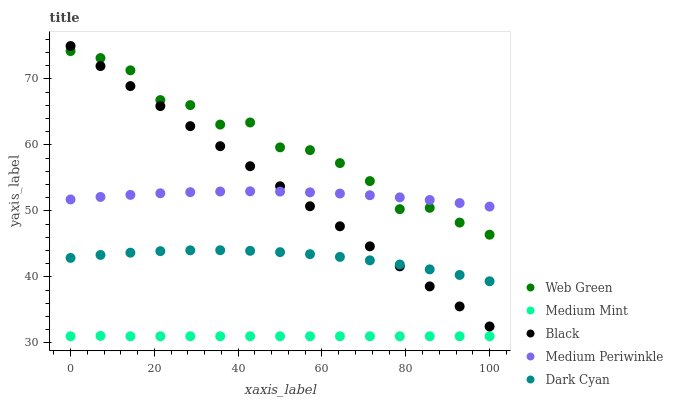Does Medium Mint have the minimum area under the curve?
Answer yes or no. Yes. Does Web Green have the maximum area under the curve?
Answer yes or no. Yes. Does Medium Periwinkle have the minimum area under the curve?
Answer yes or no. No. Does Medium Periwinkle have the maximum area under the curve?
Answer yes or no. No. Is Black the smoothest?
Answer yes or no. Yes. Is Web Green the roughest?
Answer yes or no. Yes. Is Medium Periwinkle the smoothest?
Answer yes or no. No. Is Medium Periwinkle the roughest?
Answer yes or no. No. Does Medium Mint have the lowest value?
Answer yes or no. Yes. Does Black have the lowest value?
Answer yes or no. No. Does Black have the highest value?
Answer yes or no. Yes. Does Medium Periwinkle have the highest value?
Answer yes or no. No. Is Dark Cyan less than Medium Periwinkle?
Answer yes or no. Yes. Is Medium Periwinkle greater than Dark Cyan?
Answer yes or no. Yes. Does Medium Periwinkle intersect Black?
Answer yes or no. Yes. Is Medium Periwinkle less than Black?
Answer yes or no. No. Is Medium Periwinkle greater than Black?
Answer yes or no. No. Does Dark Cyan intersect Medium Periwinkle?
Answer yes or no. No. 